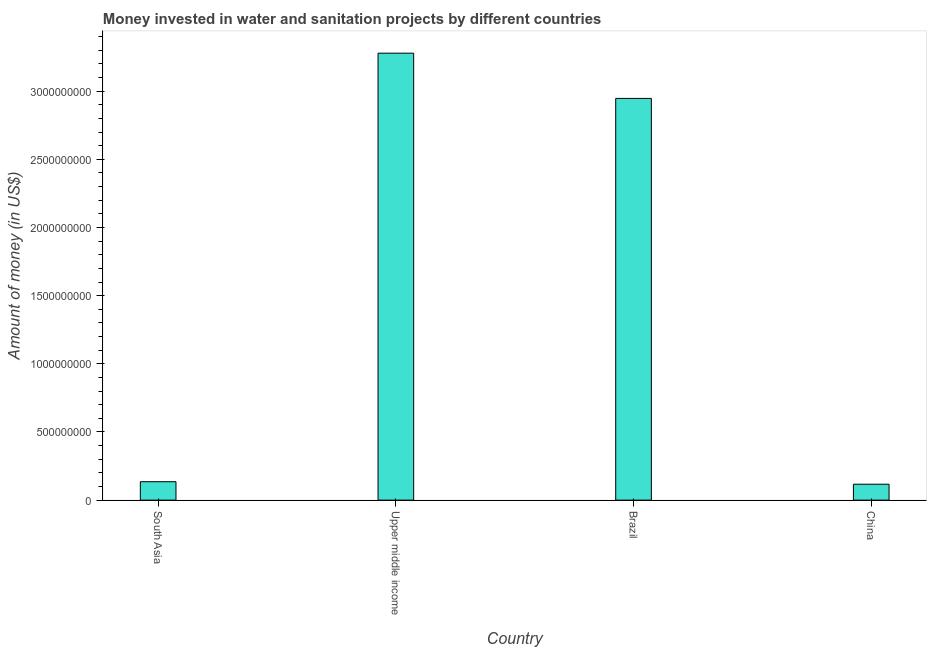Does the graph contain any zero values?
Provide a short and direct response. No. What is the title of the graph?
Give a very brief answer. Money invested in water and sanitation projects by different countries. What is the label or title of the X-axis?
Give a very brief answer. Country. What is the label or title of the Y-axis?
Provide a short and direct response. Amount of money (in US$). What is the investment in Brazil?
Offer a very short reply. 2.95e+09. Across all countries, what is the maximum investment?
Make the answer very short. 3.28e+09. Across all countries, what is the minimum investment?
Your response must be concise. 1.17e+08. In which country was the investment maximum?
Ensure brevity in your answer.  Upper middle income. In which country was the investment minimum?
Offer a terse response. China. What is the sum of the investment?
Provide a succinct answer. 6.48e+09. What is the difference between the investment in Brazil and China?
Provide a short and direct response. 2.83e+09. What is the average investment per country?
Ensure brevity in your answer.  1.62e+09. What is the median investment?
Ensure brevity in your answer.  1.54e+09. In how many countries, is the investment greater than 2800000000 US$?
Provide a short and direct response. 2. What is the ratio of the investment in China to that in Upper middle income?
Provide a succinct answer. 0.04. What is the difference between the highest and the second highest investment?
Make the answer very short. 3.32e+08. Is the sum of the investment in South Asia and Upper middle income greater than the maximum investment across all countries?
Give a very brief answer. Yes. What is the difference between the highest and the lowest investment?
Your response must be concise. 3.16e+09. What is the difference between two consecutive major ticks on the Y-axis?
Keep it short and to the point. 5.00e+08. What is the Amount of money (in US$) of South Asia?
Provide a short and direct response. 1.35e+08. What is the Amount of money (in US$) of Upper middle income?
Your answer should be very brief. 3.28e+09. What is the Amount of money (in US$) in Brazil?
Your answer should be compact. 2.95e+09. What is the Amount of money (in US$) in China?
Offer a terse response. 1.17e+08. What is the difference between the Amount of money (in US$) in South Asia and Upper middle income?
Your answer should be compact. -3.14e+09. What is the difference between the Amount of money (in US$) in South Asia and Brazil?
Your answer should be compact. -2.81e+09. What is the difference between the Amount of money (in US$) in South Asia and China?
Make the answer very short. 1.83e+07. What is the difference between the Amount of money (in US$) in Upper middle income and Brazil?
Your response must be concise. 3.32e+08. What is the difference between the Amount of money (in US$) in Upper middle income and China?
Your answer should be very brief. 3.16e+09. What is the difference between the Amount of money (in US$) in Brazil and China?
Your answer should be compact. 2.83e+09. What is the ratio of the Amount of money (in US$) in South Asia to that in Upper middle income?
Provide a short and direct response. 0.04. What is the ratio of the Amount of money (in US$) in South Asia to that in Brazil?
Offer a terse response. 0.05. What is the ratio of the Amount of money (in US$) in South Asia to that in China?
Offer a terse response. 1.16. What is the ratio of the Amount of money (in US$) in Upper middle income to that in Brazil?
Provide a short and direct response. 1.11. What is the ratio of the Amount of money (in US$) in Upper middle income to that in China?
Ensure brevity in your answer.  28.08. What is the ratio of the Amount of money (in US$) in Brazil to that in China?
Offer a terse response. 25.24. 